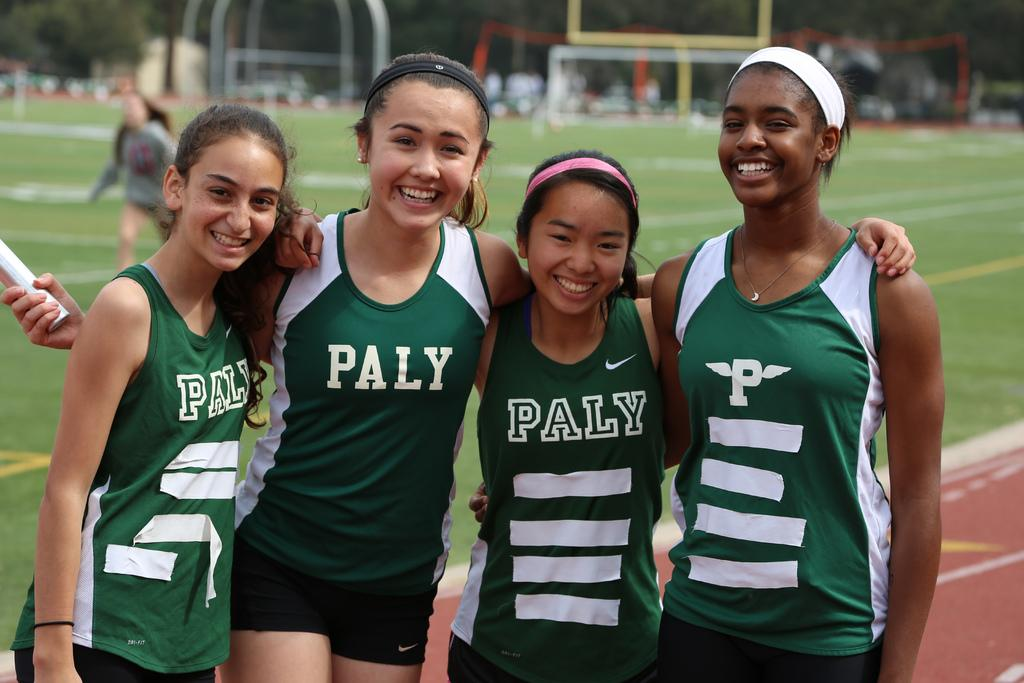Provide a one-sentence caption for the provided image. Four girls wearing "PALY" jerseys posing for a photo. 